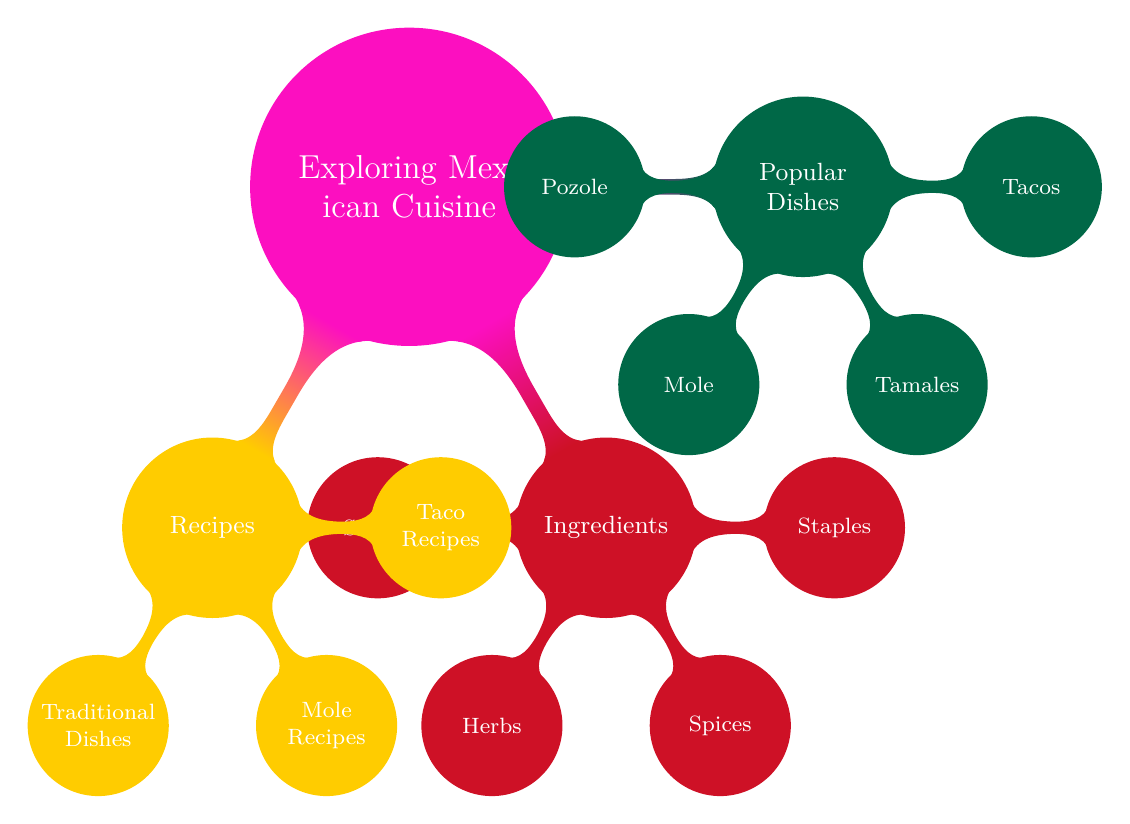What are the four categories in "Exploring Mexican Cuisine"? The mind map includes three main categories branching out from "Exploring Mexican Cuisine": Popular Dishes, Ingredients, and Recipes.
Answer: Popular Dishes, Ingredients, Recipes How many types of tacos are listed? Under the "Tacos" node within "Popular Dishes," there are three types mentioned: Al Pastor, Carnitas, and Barbacoa.
Answer: 3 Which category features "Chiles en Nogada"? "Chiles en Nogada" is found under the "Popular Dishes" category as one of the main dishes, showcasing its prominence in Mexican cuisine.
Answer: Popular Dishes What is one of the staples listed in the ingredients? The "Ingredients" node has a sub-category for "Staples," which lists Corn as one of the essential components in Mexican cuisine.
Answer: Corn How many mole recipes are included? The "Recipes" section has a dedicated part for "Mole Recipes," which contains three specific recipes: Mole Poblano Recipe, Mole Negro Recipe, and Mole Verde Recipe. Thus, the total count is three.
Answer: 3 Identify a type of sweet ingredient. Within the "Ingredients" section, the "Sweets" node includes Chocolate, pointing to the rich traditions in Mexican dessert making.
Answer: Chocolate What dish corresponds with both "Traditional Dishes" and "Pozole"? "Pozole" appears under the "Popular Dishes" as well as in the "Traditional Dishes" of the recipes section. This highlights its significance in both categories.
Answer: Pozole How many types of ingredients are specified in the diagram? The "Ingredients" main category branches into four types: Staples, Spices, Herbs, and Sweets, making a total of four different ingredient types.
Answer: 4 List one herb mentioned in the diagram. In the "Herbs" sub-category under "Ingredients," the mind map mentions Cilantro, which is a common herb used in many Mexican dishes.
Answer: Cilantro 